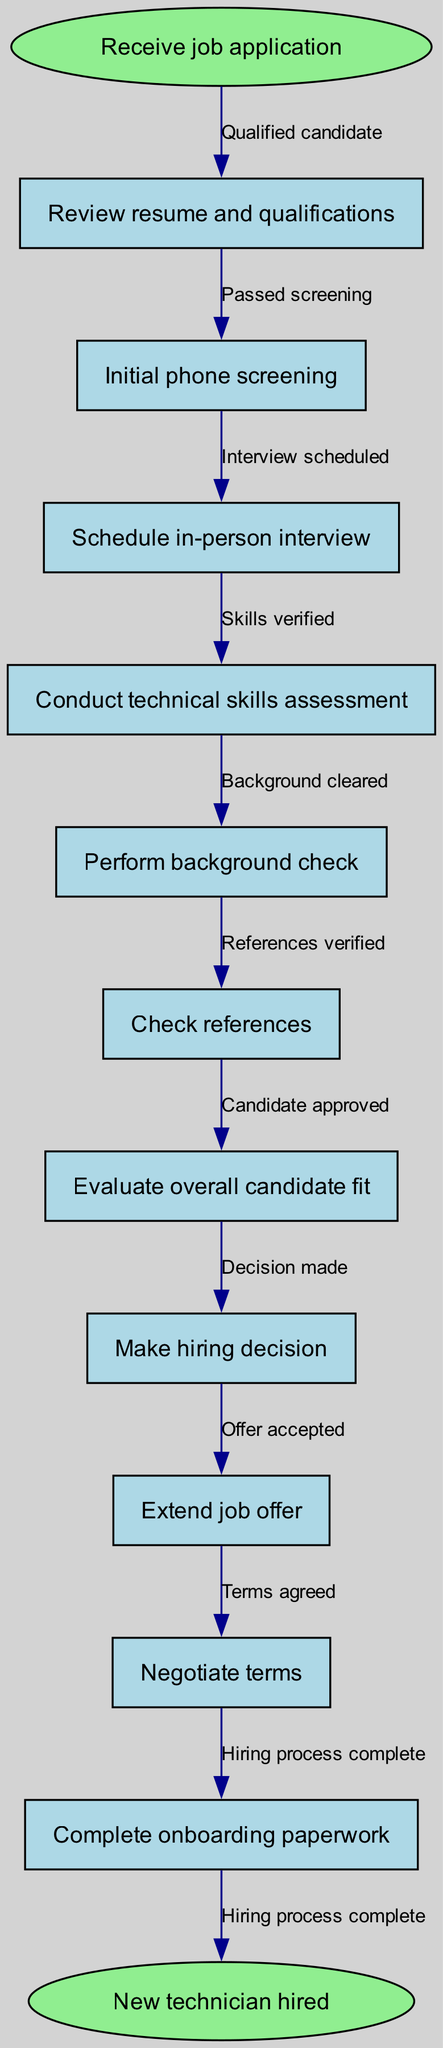What is the first step in the hiring process? The first node directly following the start node is "Receive job application," indicating it is the initial step in the hiring process.
Answer: Receive job application How many nodes are there in the diagram? Counting all the nodes listed in the diagram, there are a total of 11 nodes, including the start and end nodes.
Answer: 11 What is the last step before hiring a technician? The final step before reaching the end node is "Complete onboarding paperwork," which is the last action taken in the process.
Answer: Complete onboarding paperwork Which step follows "Conduct technical skills assessment"? The edge connecting the "Conduct technical skills assessment" node to the next node indicates that "Perform background check" is the next step in the process.
Answer: Perform background check What is the relationship between "Initial phone screening" and "Schedule in-person interview"? The edge serves as the connector between these two nodes, indicating that an initial phone screening is a prerequisite to scheduling an in-person interview.
Answer: Passed screening What is the total number of edges in the diagram? The edges are the connections between the nodes. There are 10 edges in total, indicating the relationships between the various steps in the hiring process.
Answer: 10 How many nodes relate to the candidate evaluation process? The nodes related to candidate evaluation include "Evaluate overall candidate fit" and "Check references," resulting in a total of 3 nodes that revolve around candidate evaluation.
Answer: 3 What nodes are connected by the edge labeled "Decision made"? This edge connects the node "Candidate approved" to the node "Make hiring decision," indicating that after candidate approval, the hiring decision is made.
Answer: Candidate approved and Make hiring decision Which task occurs after "Check references"? Following the "Check references" step, the diagram indicates that the next task is to "Evaluate overall candidate fit."
Answer: Evaluate overall candidate fit 